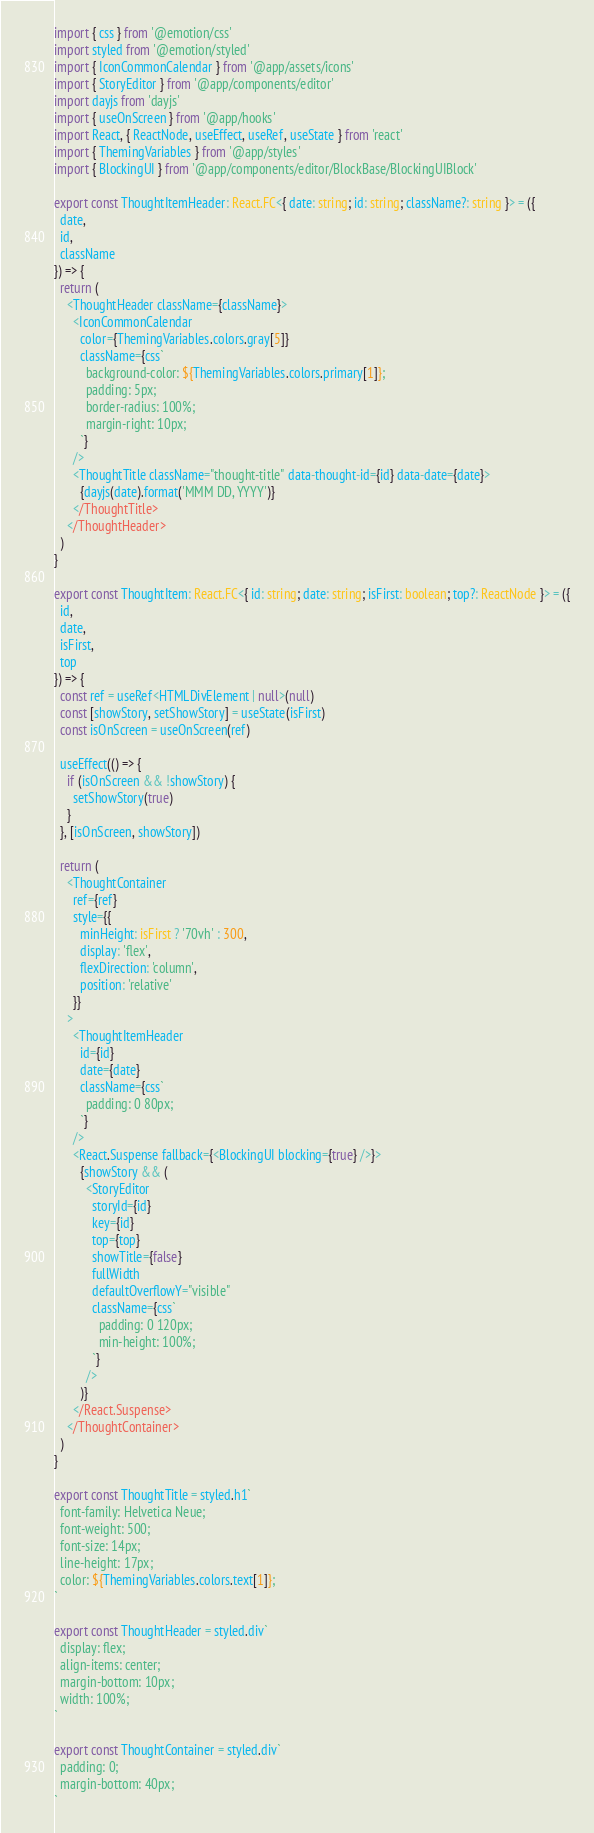Convert code to text. <code><loc_0><loc_0><loc_500><loc_500><_TypeScript_>import { css } from '@emotion/css'
import styled from '@emotion/styled'
import { IconCommonCalendar } from '@app/assets/icons'
import { StoryEditor } from '@app/components/editor'
import dayjs from 'dayjs'
import { useOnScreen } from '@app/hooks'
import React, { ReactNode, useEffect, useRef, useState } from 'react'
import { ThemingVariables } from '@app/styles'
import { BlockingUI } from '@app/components/editor/BlockBase/BlockingUIBlock'

export const ThoughtItemHeader: React.FC<{ date: string; id: string; className?: string }> = ({
  date,
  id,
  className
}) => {
  return (
    <ThoughtHeader className={className}>
      <IconCommonCalendar
        color={ThemingVariables.colors.gray[5]}
        className={css`
          background-color: ${ThemingVariables.colors.primary[1]};
          padding: 5px;
          border-radius: 100%;
          margin-right: 10px;
        `}
      />
      <ThoughtTitle className="thought-title" data-thought-id={id} data-date={date}>
        {dayjs(date).format('MMM DD, YYYY')}
      </ThoughtTitle>
    </ThoughtHeader>
  )
}

export const ThoughtItem: React.FC<{ id: string; date: string; isFirst: boolean; top?: ReactNode }> = ({
  id,
  date,
  isFirst,
  top
}) => {
  const ref = useRef<HTMLDivElement | null>(null)
  const [showStory, setShowStory] = useState(isFirst)
  const isOnScreen = useOnScreen(ref)

  useEffect(() => {
    if (isOnScreen && !showStory) {
      setShowStory(true)
    }
  }, [isOnScreen, showStory])

  return (
    <ThoughtContainer
      ref={ref}
      style={{
        minHeight: isFirst ? '70vh' : 300,
        display: 'flex',
        flexDirection: 'column',
        position: 'relative'
      }}
    >
      <ThoughtItemHeader
        id={id}
        date={date}
        className={css`
          padding: 0 80px;
        `}
      />
      <React.Suspense fallback={<BlockingUI blocking={true} />}>
        {showStory && (
          <StoryEditor
            storyId={id}
            key={id}
            top={top}
            showTitle={false}
            fullWidth
            defaultOverflowY="visible"
            className={css`
              padding: 0 120px;
              min-height: 100%;
            `}
          />
        )}
      </React.Suspense>
    </ThoughtContainer>
  )
}

export const ThoughtTitle = styled.h1`
  font-family: Helvetica Neue;
  font-weight: 500;
  font-size: 14px;
  line-height: 17px;
  color: ${ThemingVariables.colors.text[1]};
`

export const ThoughtHeader = styled.div`
  display: flex;
  align-items: center;
  margin-bottom: 10px;
  width: 100%;
`

export const ThoughtContainer = styled.div`
  padding: 0;
  margin-bottom: 40px;
`
</code> 